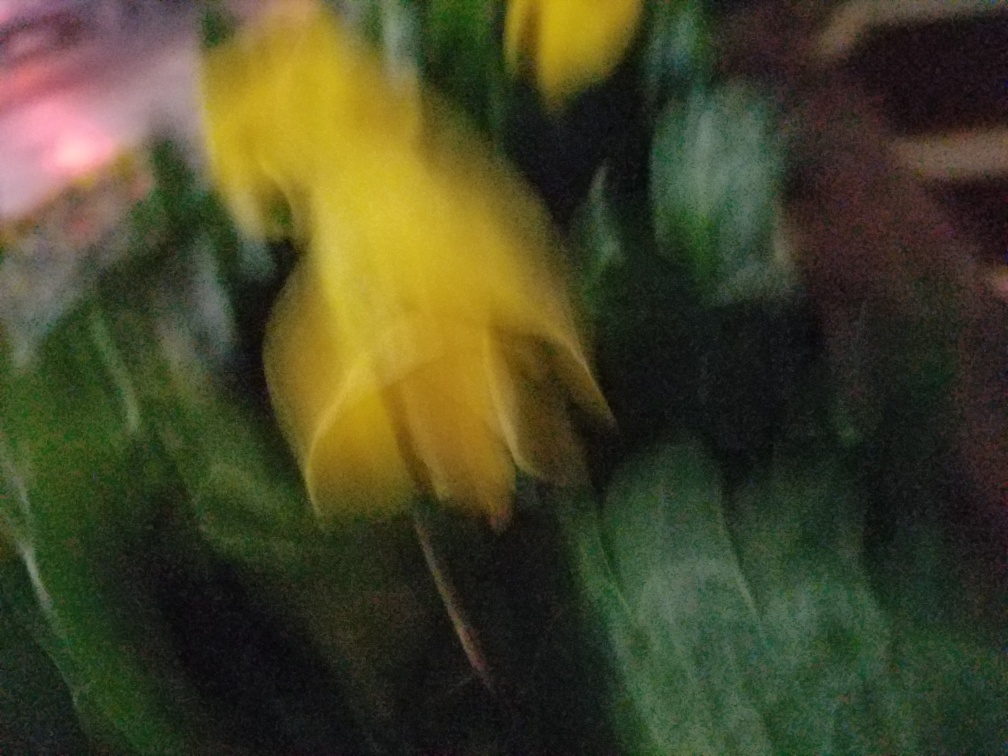What is the quality of this photo?
A. Average.
B. Very poor.
C. Moderate. The quality of the photo is quite low. The image is blurry and the details are not clear, which often denotes a very poor capture, possibly due to camera shake or focus issues. The colors seem vivid, but the lack of sharpness hinders any proper assessment of its content. 